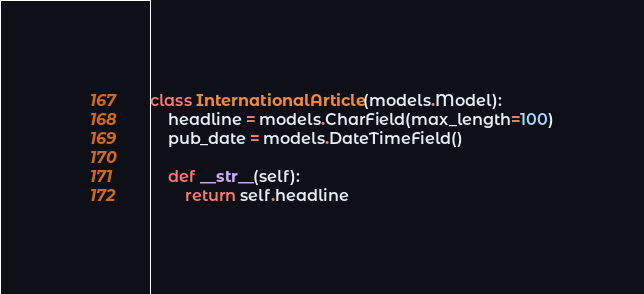<code> <loc_0><loc_0><loc_500><loc_500><_Python_>class InternationalArticle(models.Model):
    headline = models.CharField(max_length=100)
    pub_date = models.DateTimeField()

    def __str__(self):
        return self.headline
</code> 